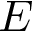<formula> <loc_0><loc_0><loc_500><loc_500>E</formula> 